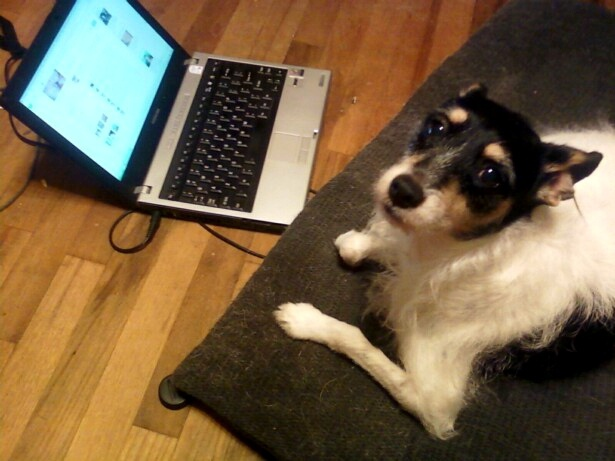Describe the objects in this image and their specific colors. I can see dog in maroon, black, tan, and beige tones and laptop in maroon, black, cyan, ivory, and tan tones in this image. 